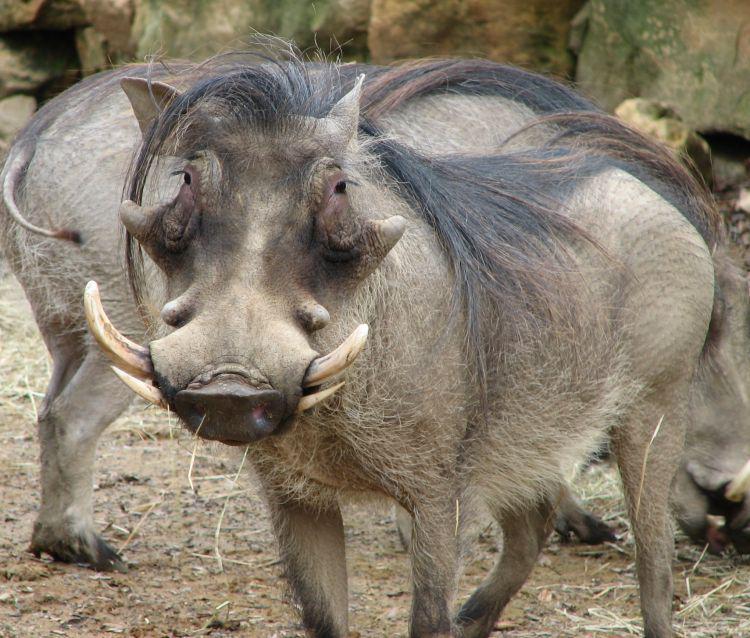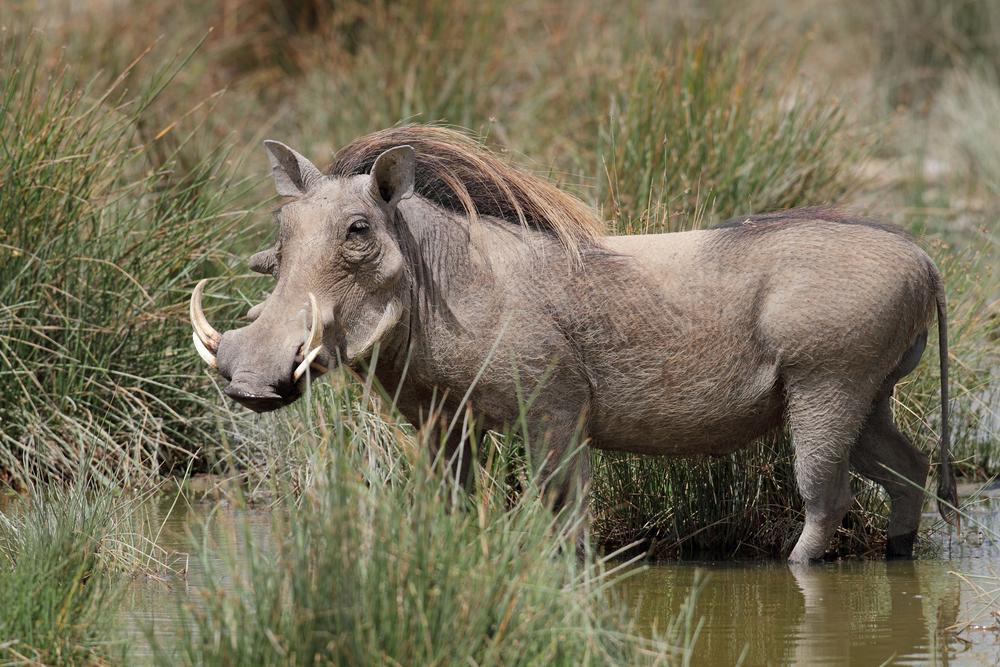The first image is the image on the left, the second image is the image on the right. For the images shown, is this caption "More than one warthog is present in one of the images." true? Answer yes or no. Yes. 